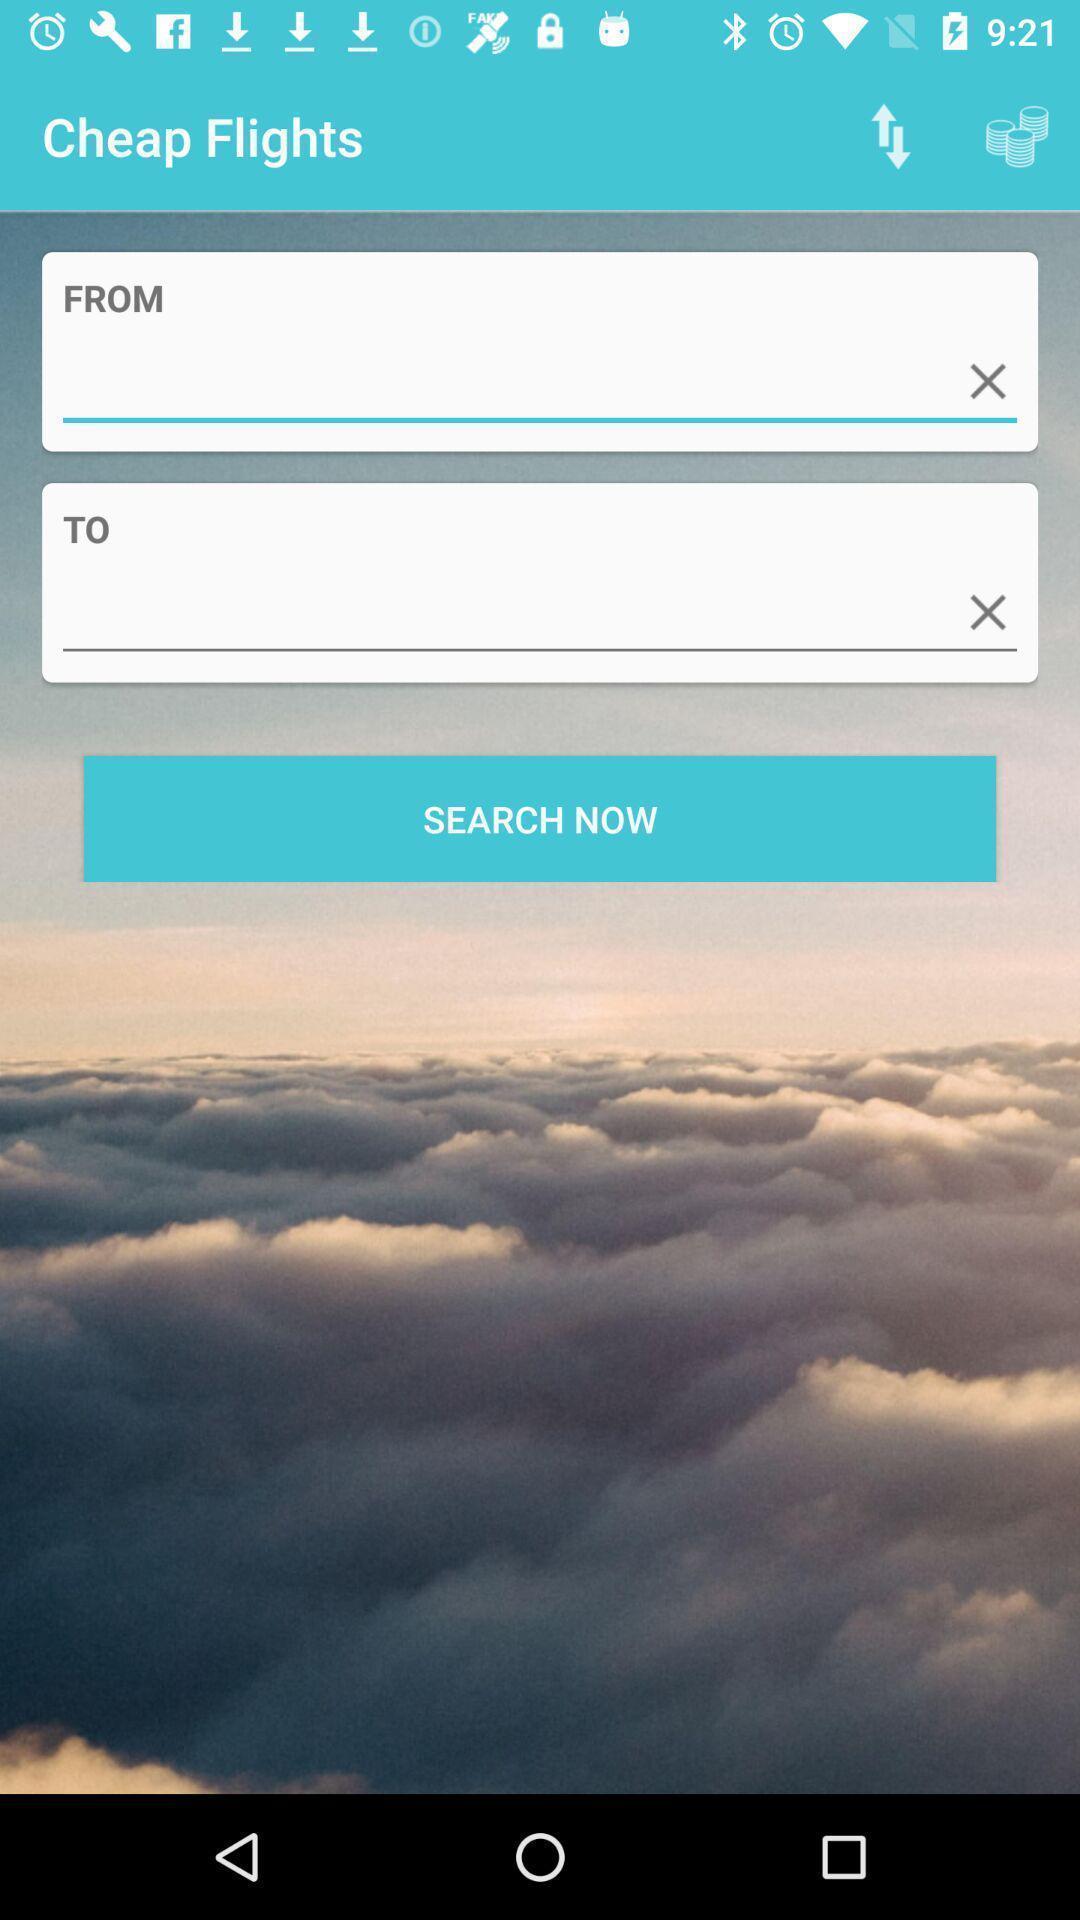Describe the content in this image. Search page for searching a flights. 